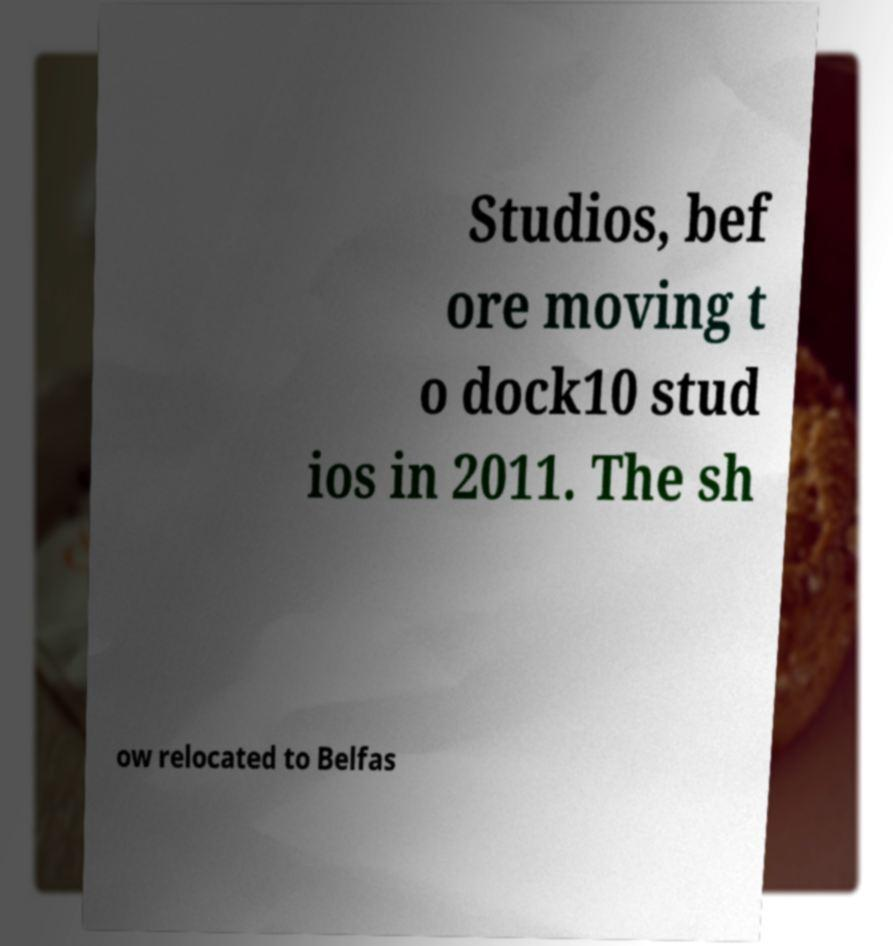For documentation purposes, I need the text within this image transcribed. Could you provide that? Studios, bef ore moving t o dock10 stud ios in 2011. The sh ow relocated to Belfas 